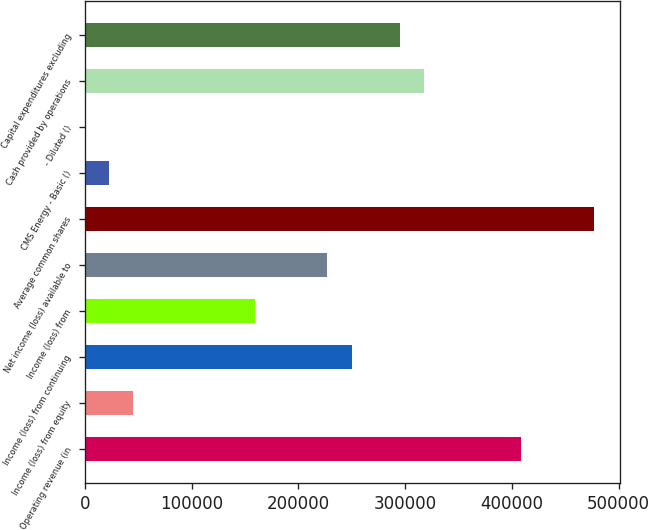<chart> <loc_0><loc_0><loc_500><loc_500><bar_chart><fcel>Operating revenue (in<fcel>Income (loss) from equity<fcel>Income (loss) from continuing<fcel>Income (loss) from<fcel>Net income (loss) available to<fcel>Average common shares<fcel>CMS Energy - Basic ()<fcel>- Diluted ()<fcel>Cash provided by operations<fcel>Capital expenditures excluding<nl><fcel>408904<fcel>45434.5<fcel>249886<fcel>159019<fcel>227169<fcel>477054<fcel>22717.7<fcel>0.83<fcel>318036<fcel>295319<nl></chart> 